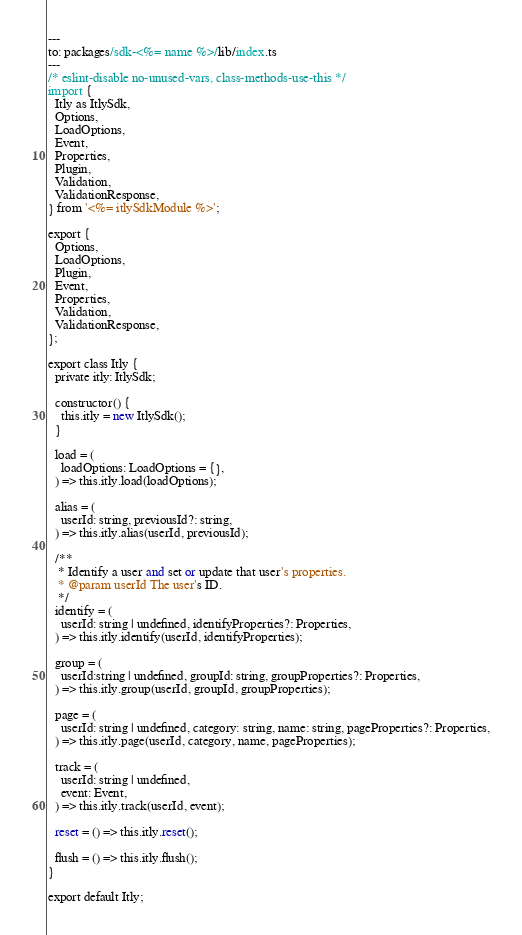<code> <loc_0><loc_0><loc_500><loc_500><_Perl_>---
to: packages/sdk-<%= name %>/lib/index.ts
---
/* eslint-disable no-unused-vars, class-methods-use-this */
import {
  Itly as ItlySdk,
  Options,
  LoadOptions,
  Event,
  Properties,
  Plugin,
  Validation,
  ValidationResponse,
} from '<%= itlySdkModule %>';

export {
  Options,
  LoadOptions,
  Plugin,
  Event,
  Properties,
  Validation,
  ValidationResponse,
};

export class Itly {
  private itly: ItlySdk;

  constructor() {
    this.itly = new ItlySdk();
  }

  load = (
    loadOptions: LoadOptions = {},
  ) => this.itly.load(loadOptions);

  alias = (
    userId: string, previousId?: string,
  ) => this.itly.alias(userId, previousId);

  /**
   * Identify a user and set or update that user's properties.
   * @param userId The user's ID.
   */
  identify = (
    userId: string | undefined, identifyProperties?: Properties,
  ) => this.itly.identify(userId, identifyProperties);

  group = (
    userId:string | undefined, groupId: string, groupProperties?: Properties,
  ) => this.itly.group(userId, groupId, groupProperties);

  page = (
    userId: string | undefined, category: string, name: string, pageProperties?: Properties,
  ) => this.itly.page(userId, category, name, pageProperties);

  track = (
    userId: string | undefined,
    event: Event,
  ) => this.itly.track(userId, event);

  reset = () => this.itly.reset();

  flush = () => this.itly.flush();
}

export default Itly;
</code> 